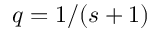Convert formula to latex. <formula><loc_0><loc_0><loc_500><loc_500>q = 1 / ( s + 1 )</formula> 